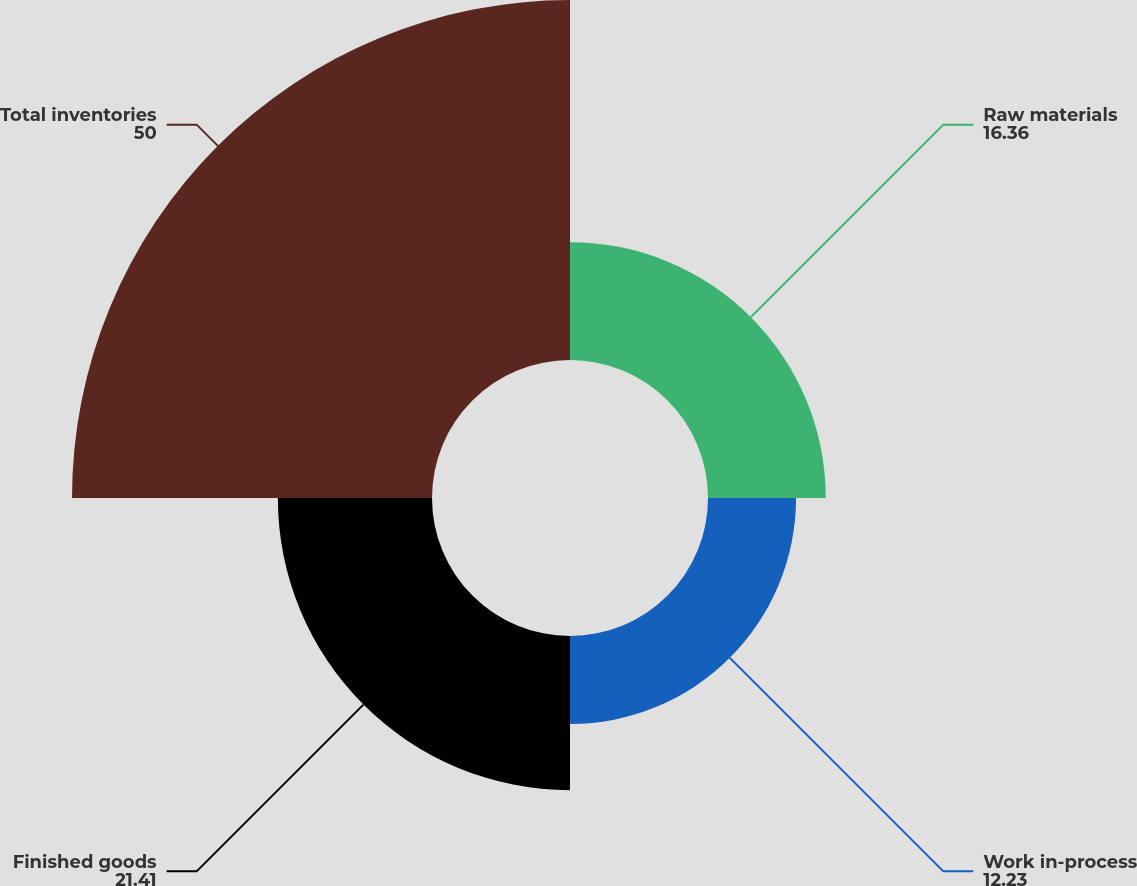<chart> <loc_0><loc_0><loc_500><loc_500><pie_chart><fcel>Raw materials<fcel>Work in-process<fcel>Finished goods<fcel>Total inventories<nl><fcel>16.36%<fcel>12.23%<fcel>21.41%<fcel>50.0%<nl></chart> 